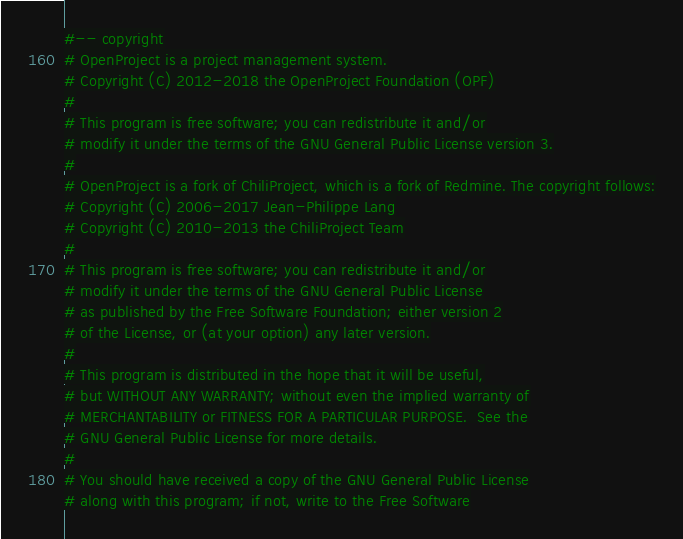Convert code to text. <code><loc_0><loc_0><loc_500><loc_500><_Ruby_>#-- copyright
# OpenProject is a project management system.
# Copyright (C) 2012-2018 the OpenProject Foundation (OPF)
#
# This program is free software; you can redistribute it and/or
# modify it under the terms of the GNU General Public License version 3.
#
# OpenProject is a fork of ChiliProject, which is a fork of Redmine. The copyright follows:
# Copyright (C) 2006-2017 Jean-Philippe Lang
# Copyright (C) 2010-2013 the ChiliProject Team
#
# This program is free software; you can redistribute it and/or
# modify it under the terms of the GNU General Public License
# as published by the Free Software Foundation; either version 2
# of the License, or (at your option) any later version.
#
# This program is distributed in the hope that it will be useful,
# but WITHOUT ANY WARRANTY; without even the implied warranty of
# MERCHANTABILITY or FITNESS FOR A PARTICULAR PURPOSE.  See the
# GNU General Public License for more details.
#
# You should have received a copy of the GNU General Public License
# along with this program; if not, write to the Free Software</code> 